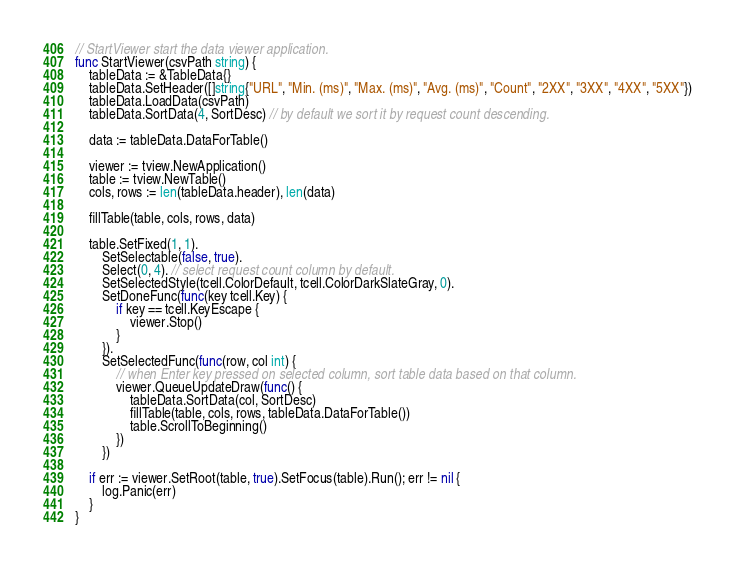<code> <loc_0><loc_0><loc_500><loc_500><_Go_>
// StartViewer start the data viewer application.
func StartViewer(csvPath string) {
	tableData := &TableData{}
	tableData.SetHeader([]string{"URL", "Min. (ms)", "Max. (ms)", "Avg. (ms)", "Count", "2XX", "3XX", "4XX", "5XX"})
	tableData.LoadData(csvPath)
	tableData.SortData(4, SortDesc) // by default we sort it by request count descending.

	data := tableData.DataForTable()

	viewer := tview.NewApplication()
	table := tview.NewTable()
	cols, rows := len(tableData.header), len(data)

	fillTable(table, cols, rows, data)

	table.SetFixed(1, 1).
		SetSelectable(false, true).
		Select(0, 4). // select request count column by default.
		SetSelectedStyle(tcell.ColorDefault, tcell.ColorDarkSlateGray, 0).
		SetDoneFunc(func(key tcell.Key) {
			if key == tcell.KeyEscape {
				viewer.Stop()
			}
		}).
		SetSelectedFunc(func(row, col int) {
			// when Enter key pressed on selected column, sort table data based on that column.
			viewer.QueueUpdateDraw(func() {
				tableData.SortData(col, SortDesc)
				fillTable(table, cols, rows, tableData.DataForTable())
				table.ScrollToBeginning()
			})
		})

	if err := viewer.SetRoot(table, true).SetFocus(table).Run(); err != nil {
		log.Panic(err)
	}
}
</code> 